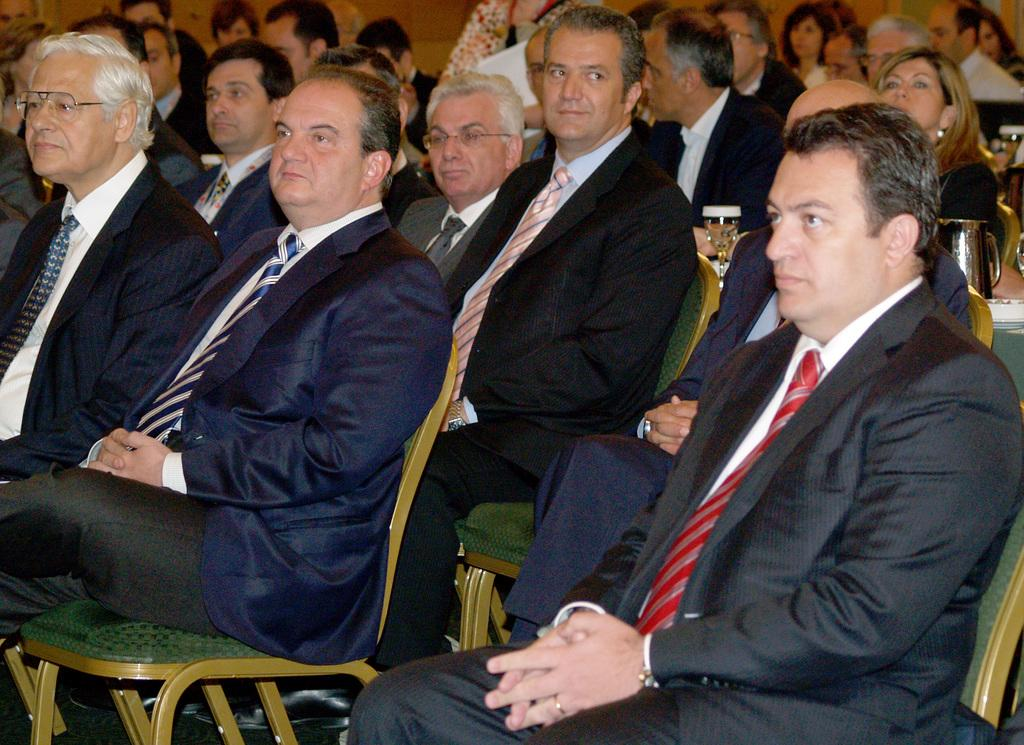What is the main subject of the image? The main subject of the image is a crowd. How are the people in the crowd positioned? The people in the crowd are sitting on chairs. What is placed between the chairs? There is a table placed between the chairs. What can be seen on the table? There is a jug and a glass tumbler with a beverage on the table. What type of cheese is being discussed by the crowd in the image? There is no mention of cheese or any discussion in the image; it simply shows a crowd of people sitting on chairs with a table and some items on it. 